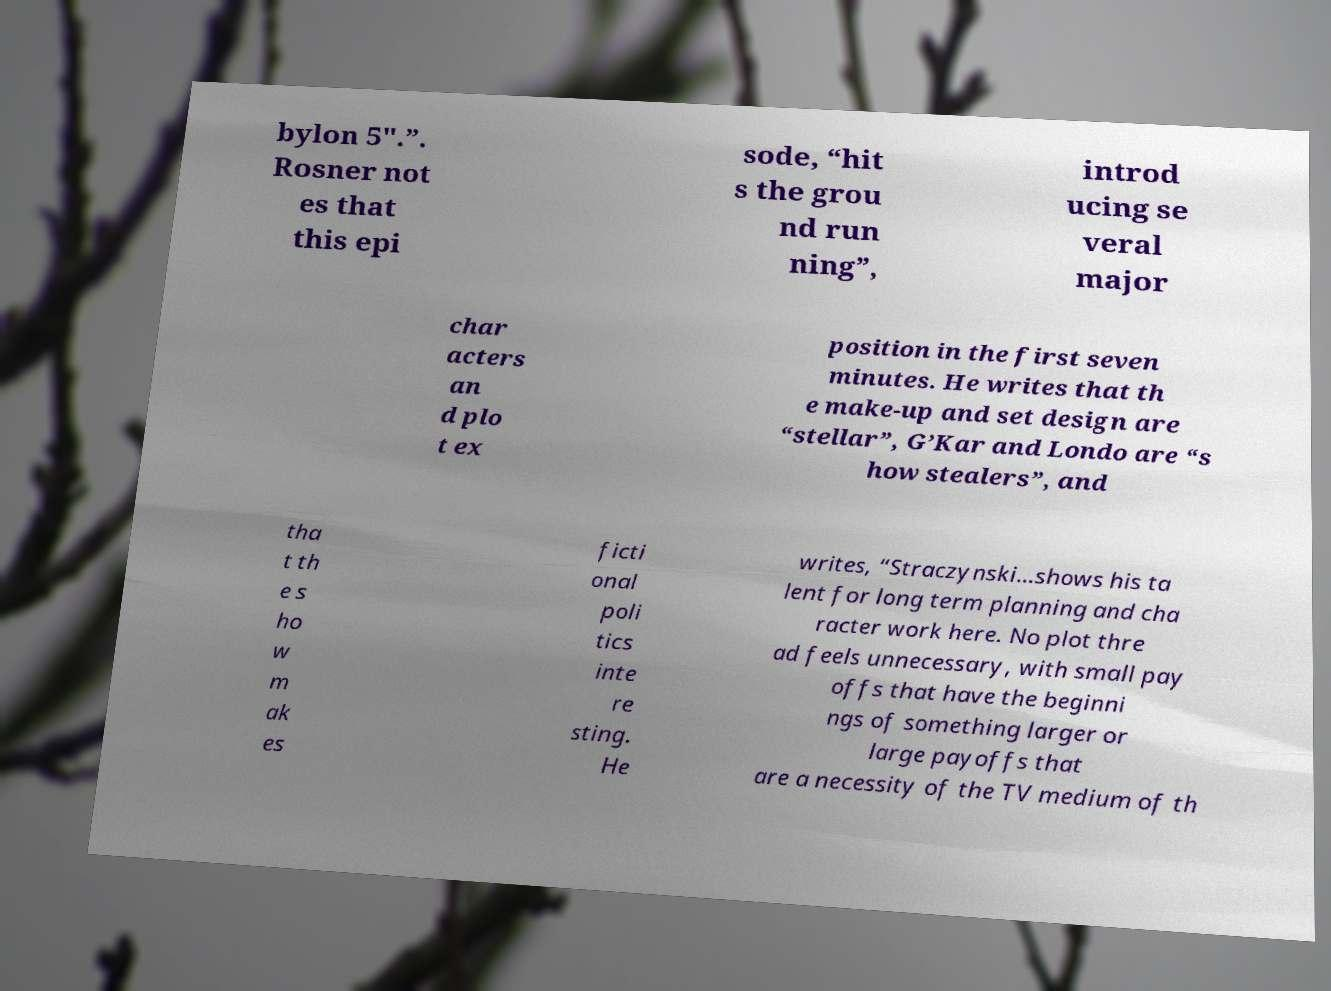I need the written content from this picture converted into text. Can you do that? bylon 5".”. Rosner not es that this epi sode, “hit s the grou nd run ning”, introd ucing se veral major char acters an d plo t ex position in the first seven minutes. He writes that th e make-up and set design are “stellar”, G’Kar and Londo are “s how stealers”, and tha t th e s ho w m ak es ficti onal poli tics inte re sting. He writes, “Straczynski…shows his ta lent for long term planning and cha racter work here. No plot thre ad feels unnecessary, with small pay offs that have the beginni ngs of something larger or large payoffs that are a necessity of the TV medium of th 